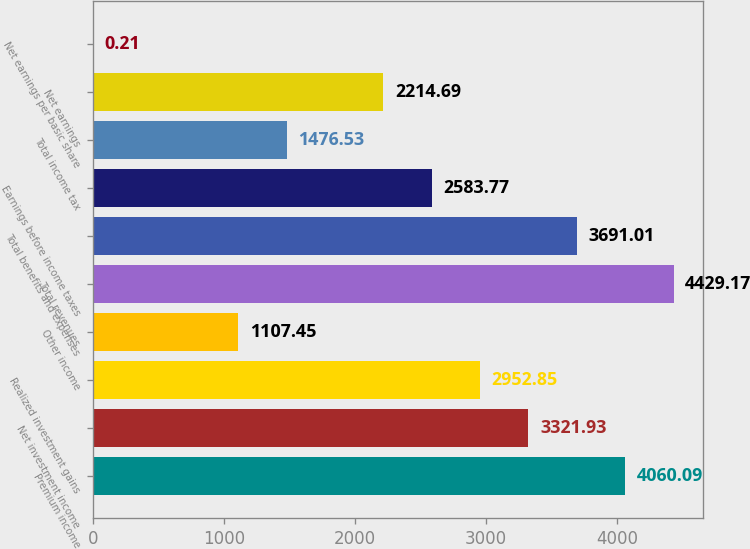<chart> <loc_0><loc_0><loc_500><loc_500><bar_chart><fcel>Premium income<fcel>Net investment income<fcel>Realized investment gains<fcel>Other income<fcel>Total revenues<fcel>Total benefits and expenses<fcel>Earnings before income taxes<fcel>Total income tax<fcel>Net earnings<fcel>Net earnings per basic share<nl><fcel>4060.09<fcel>3321.93<fcel>2952.85<fcel>1107.45<fcel>4429.17<fcel>3691.01<fcel>2583.77<fcel>1476.53<fcel>2214.69<fcel>0.21<nl></chart> 